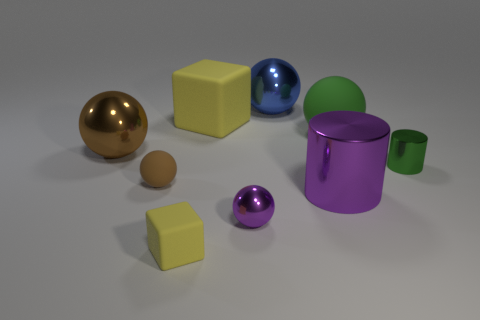How many things are big yellow blocks or balls that are to the right of the big yellow matte object?
Your answer should be very brief. 4. The big purple object is what shape?
Make the answer very short. Cylinder. Does the small matte block have the same color as the large matte block?
Your answer should be compact. Yes. The rubber cube that is the same size as the purple ball is what color?
Make the answer very short. Yellow. What number of red objects are large cubes or tiny objects?
Give a very brief answer. 0. Is the number of big shiny cylinders greater than the number of brown objects?
Your answer should be compact. No. Does the shiny object on the left side of the tiny brown thing have the same size as the matte ball in front of the brown metal object?
Provide a short and direct response. No. The block in front of the large ball that is on the right side of the shiny cylinder that is in front of the green metallic cylinder is what color?
Ensure brevity in your answer.  Yellow. Is there a green rubber thing that has the same shape as the small purple thing?
Your response must be concise. Yes. Are there more blue metallic objects behind the big brown shiny thing than big cyan spheres?
Offer a terse response. Yes. 